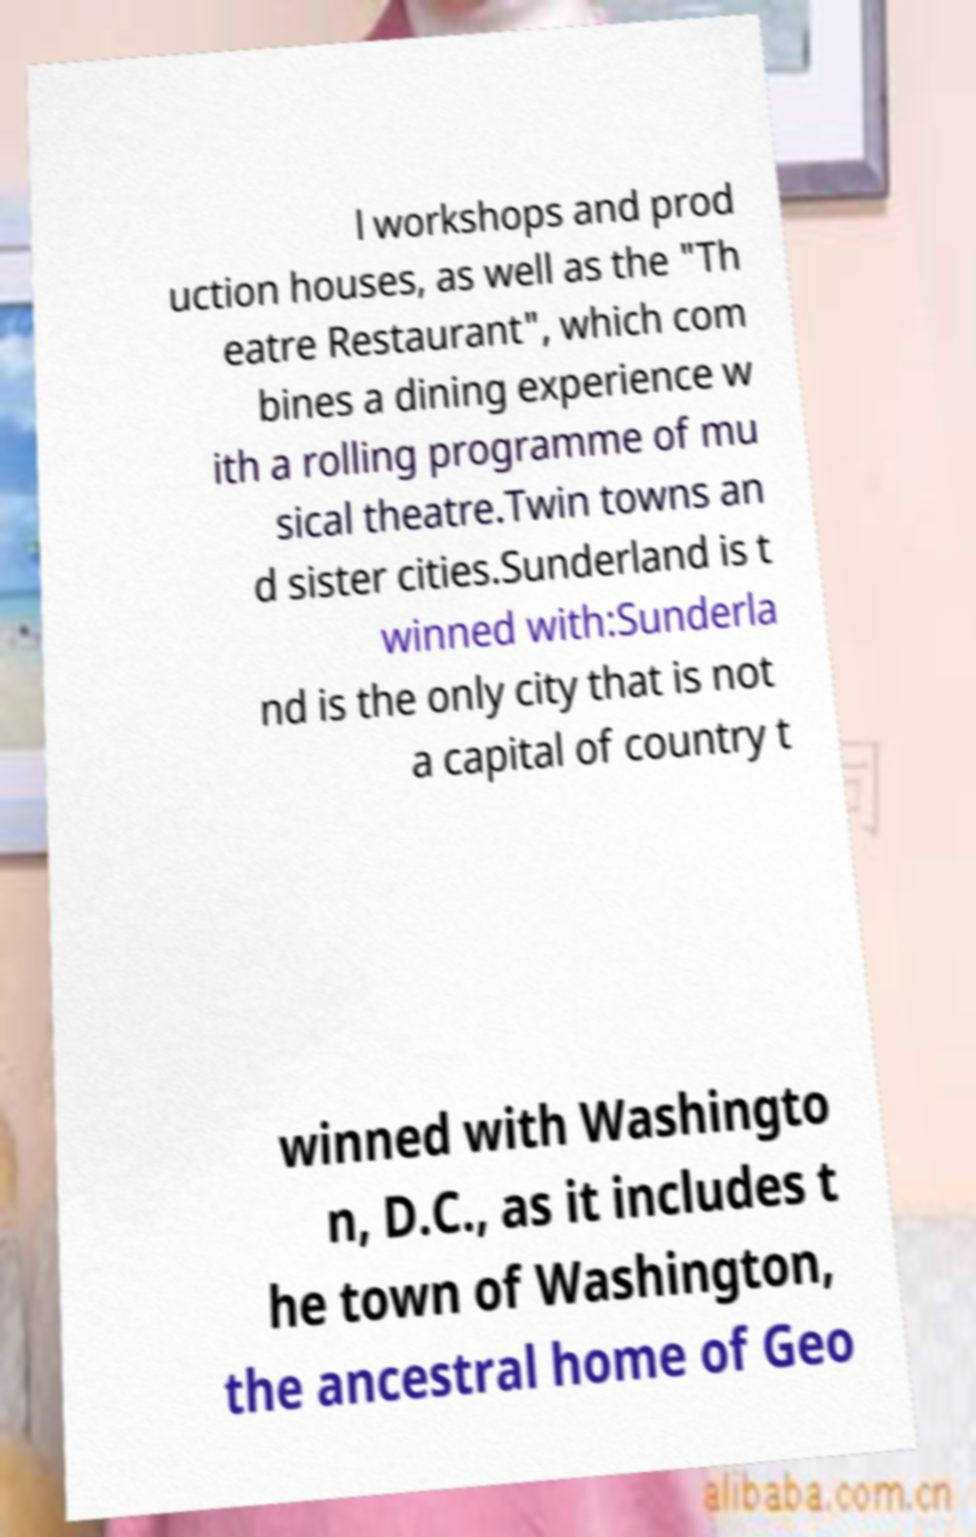Please identify and transcribe the text found in this image. l workshops and prod uction houses, as well as the "Th eatre Restaurant", which com bines a dining experience w ith a rolling programme of mu sical theatre.Twin towns an d sister cities.Sunderland is t winned with:Sunderla nd is the only city that is not a capital of country t winned with Washingto n, D.C., as it includes t he town of Washington, the ancestral home of Geo 